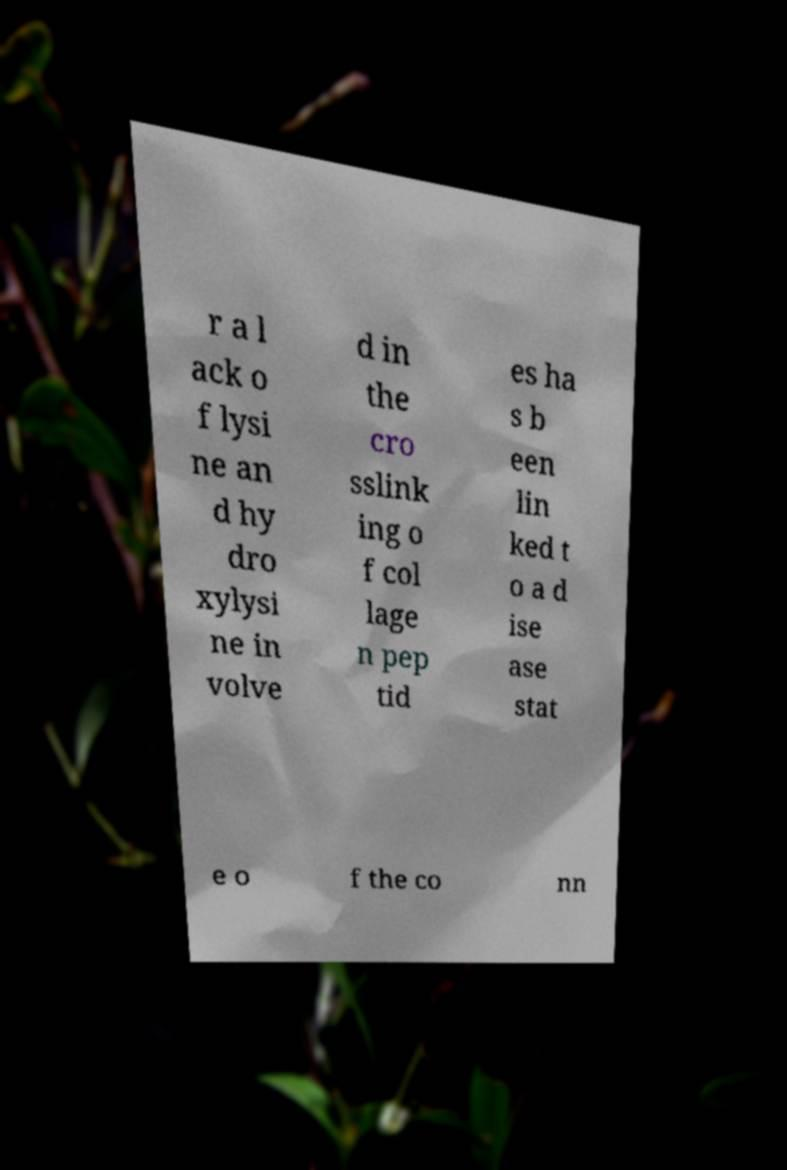I need the written content from this picture converted into text. Can you do that? r a l ack o f lysi ne an d hy dro xylysi ne in volve d in the cro sslink ing o f col lage n pep tid es ha s b een lin ked t o a d ise ase stat e o f the co nn 